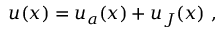<formula> <loc_0><loc_0><loc_500><loc_500>u ( x ) = u _ { a } ( x ) + u _ { J } ( x ) \ ,</formula> 